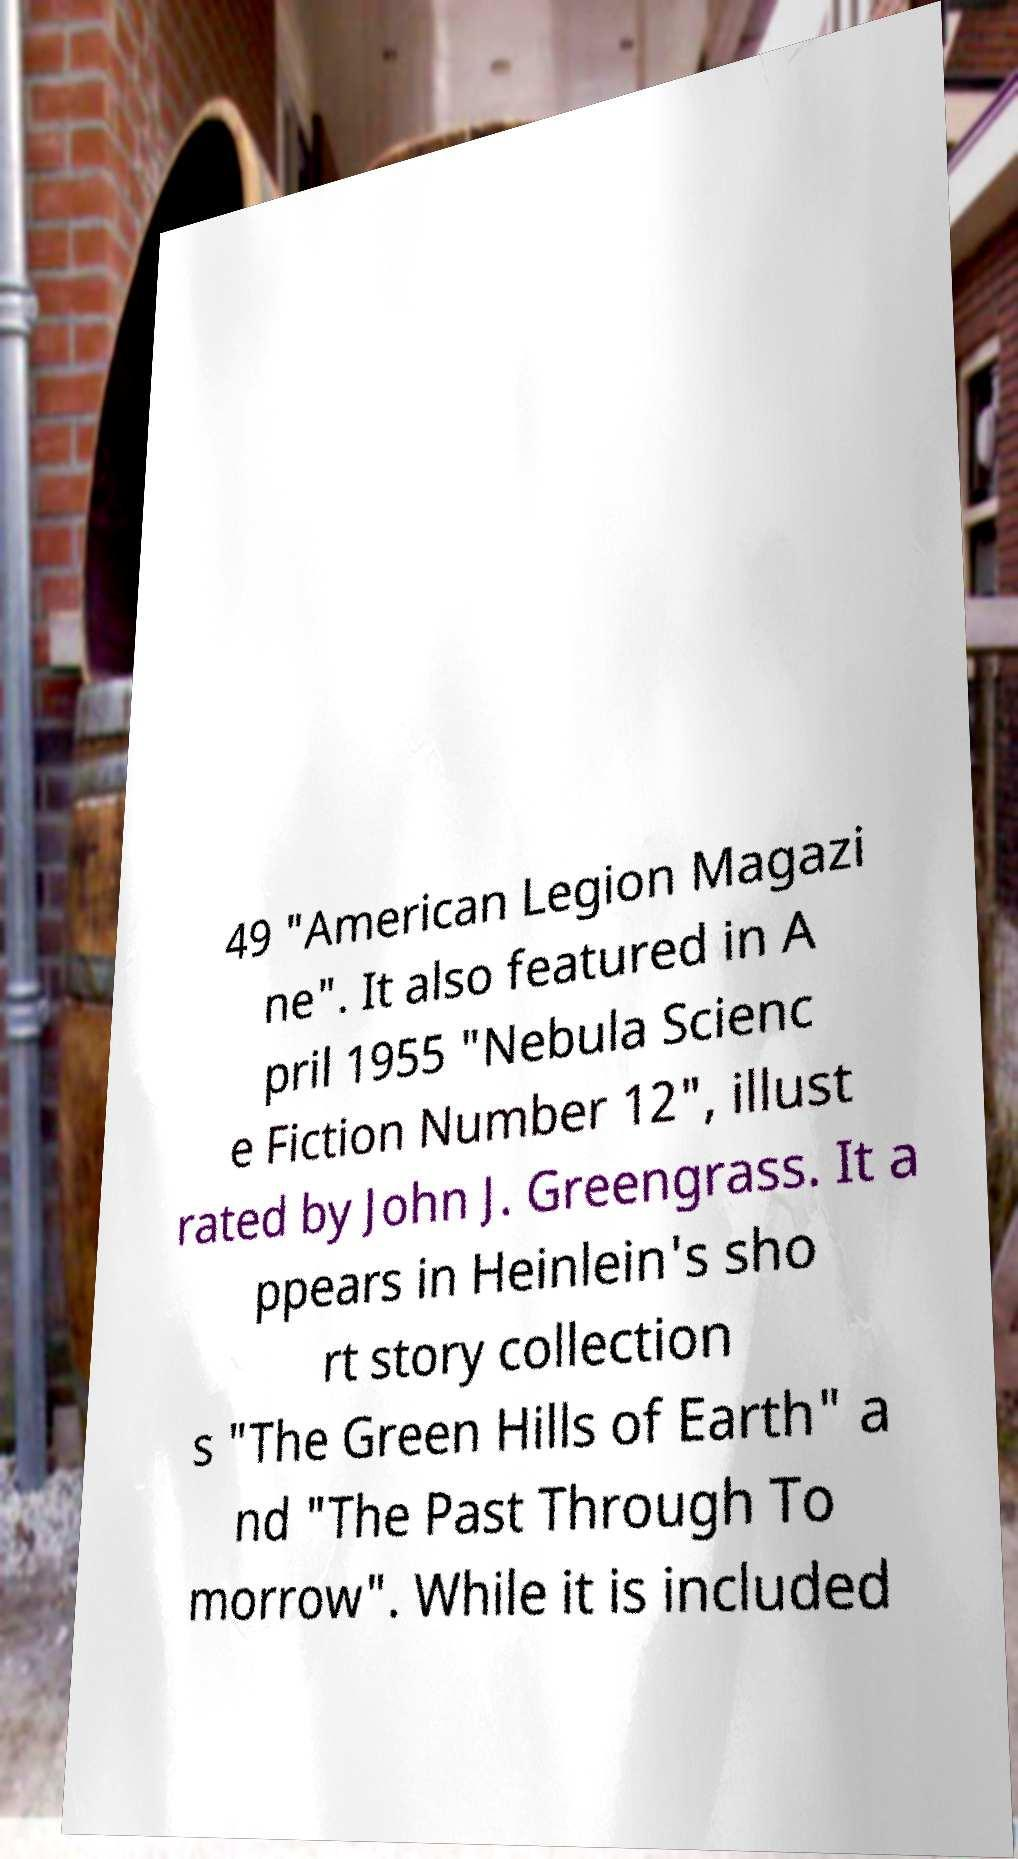There's text embedded in this image that I need extracted. Can you transcribe it verbatim? 49 "American Legion Magazi ne". It also featured in A pril 1955 "Nebula Scienc e Fiction Number 12", illust rated by John J. Greengrass. It a ppears in Heinlein's sho rt story collection s "The Green Hills of Earth" a nd "The Past Through To morrow". While it is included 